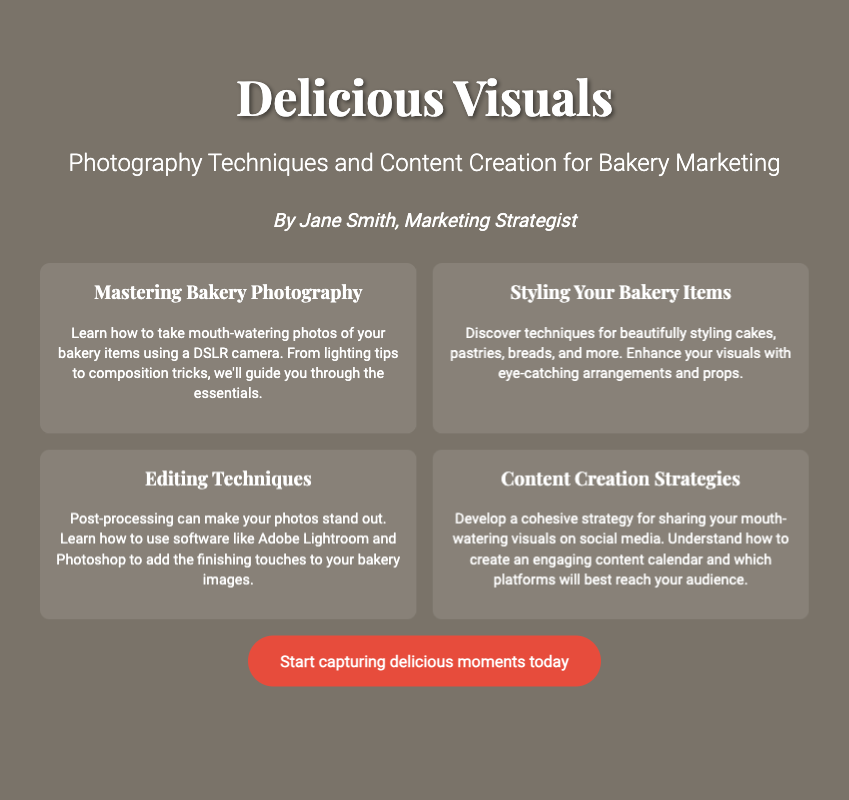what is the title of the book? The title of the book is the main prominent heading in the document.
Answer: Delicious Visuals who is the author of the book? The author of the book is mentioned in the document in a specific section that highlights their name.
Answer: Jane Smith what is the subtitle of the book? The subtitle provides additional context and is situated under the title in the document.
Answer: Photography Techniques and Content Creation for Bakery Marketing how many elements are listed on the cover? The number of elements is indicated in the section that describes various aspects related to bakery photography and marketing.
Answer: Four what is one editing technique mentioned? One editing technique is revealed in the description of the relevant element discussing editing in photography.
Answer: Adobe Lightroom what is a focus area of the book? The focus area is identified within the context of the book cover content that outlines key themes or topics.
Answer: Bakery Photography what is the call to action on the cover? The call to action is a motivating phrase that prompts the reader to take a specific action, located at the end of the content section.
Answer: Start capturing delicious moments today what kind of camera is emphasized in the book? The type of camera is specified in the section discussing photography techniques for capturing bakery items.
Answer: DSLR camera what is the background color of the book cover? The background color is described in the document's style section where color is detailed for the overall design.
Answer: #f5e6d3 